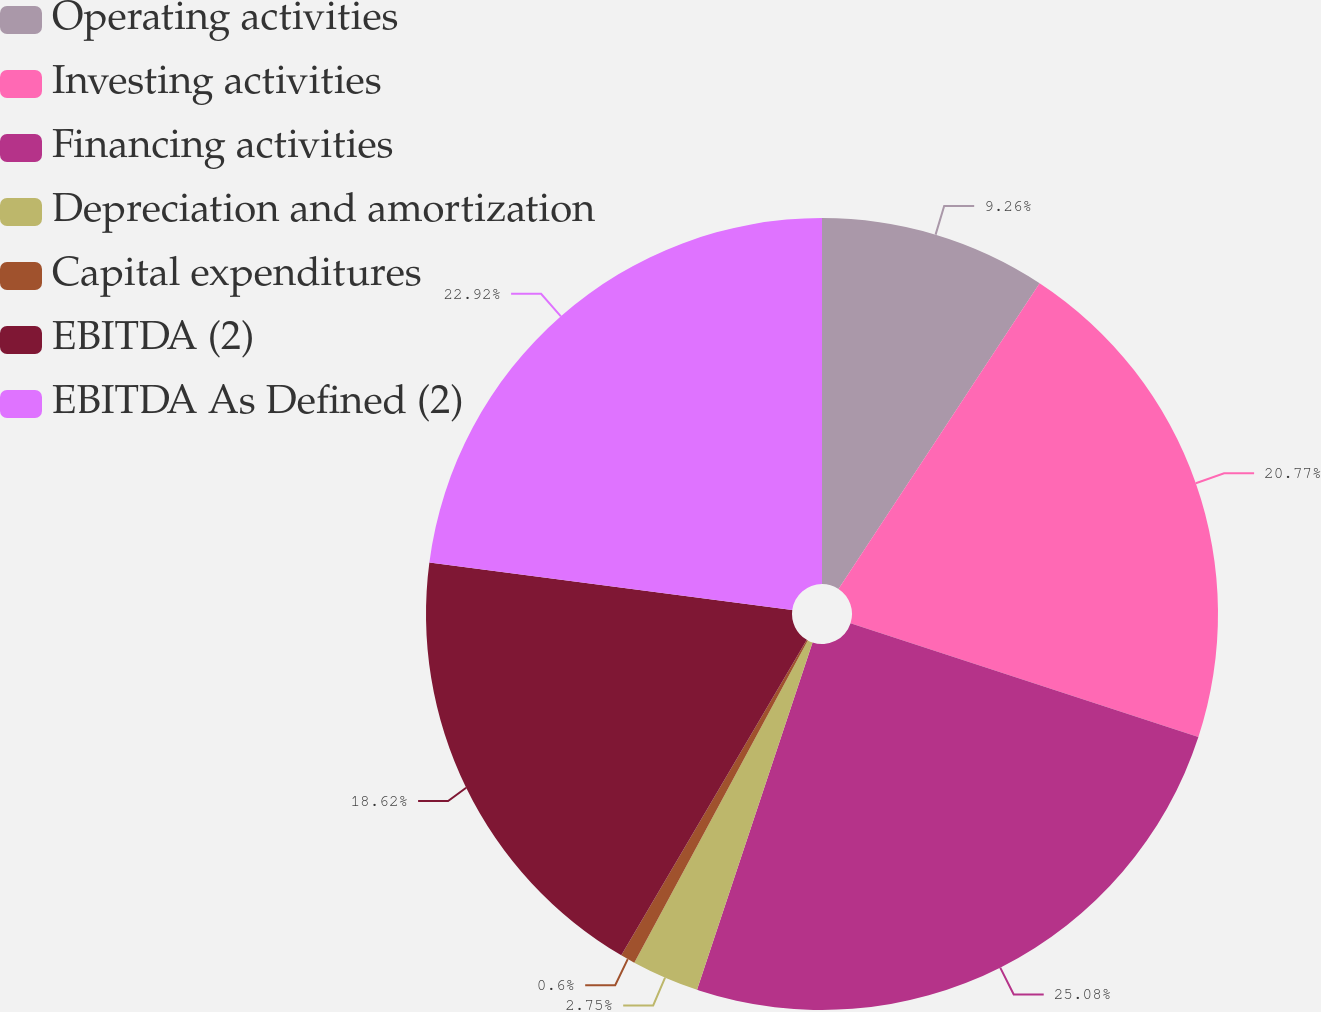<chart> <loc_0><loc_0><loc_500><loc_500><pie_chart><fcel>Operating activities<fcel>Investing activities<fcel>Financing activities<fcel>Depreciation and amortization<fcel>Capital expenditures<fcel>EBITDA (2)<fcel>EBITDA As Defined (2)<nl><fcel>9.26%<fcel>20.77%<fcel>25.08%<fcel>2.75%<fcel>0.6%<fcel>18.62%<fcel>22.92%<nl></chart> 